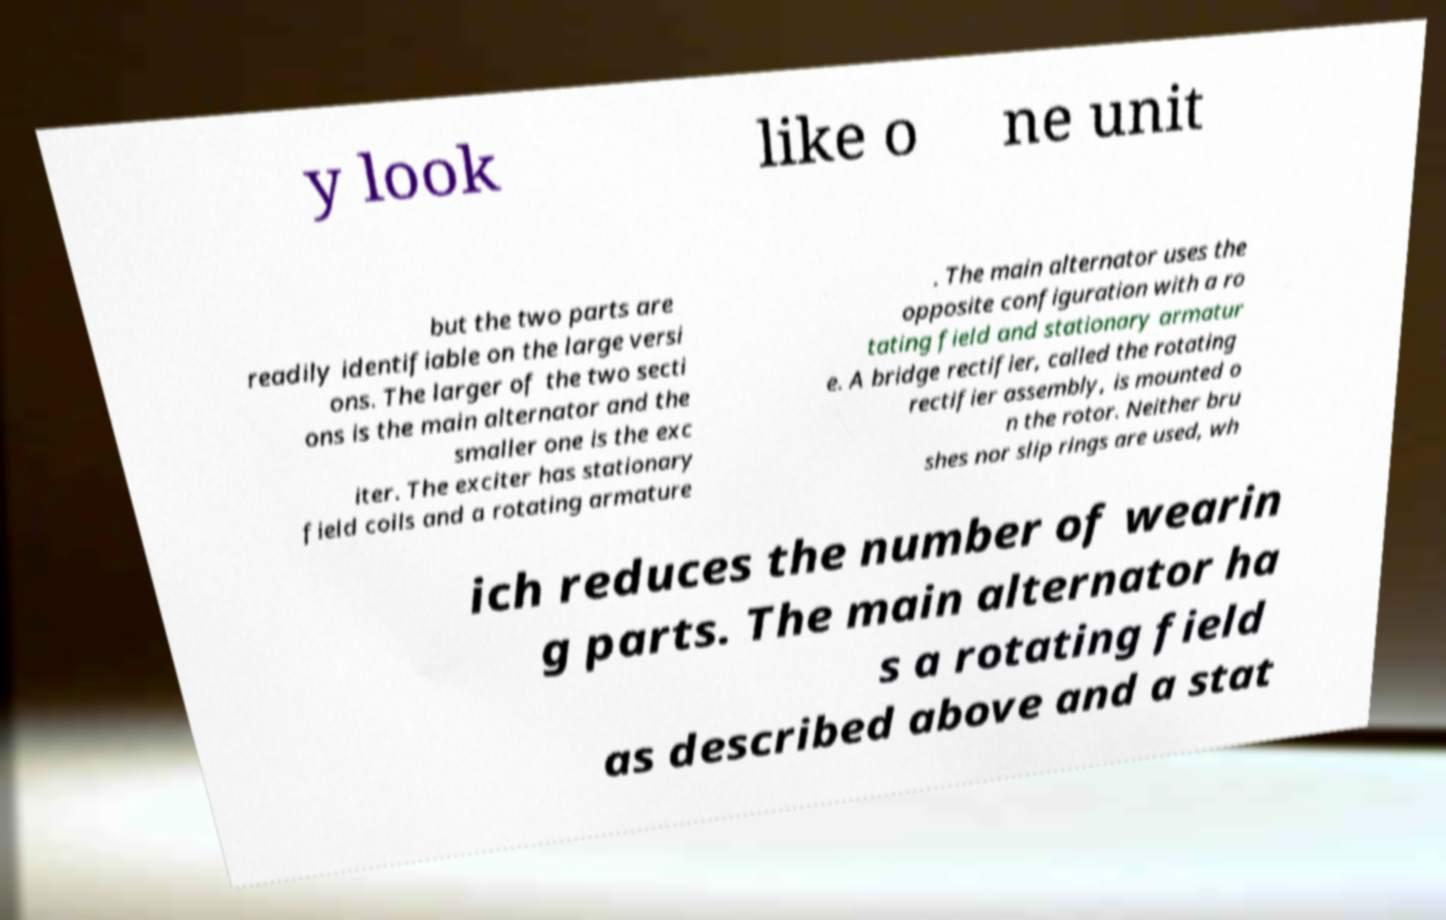Could you assist in decoding the text presented in this image and type it out clearly? y look like o ne unit but the two parts are readily identifiable on the large versi ons. The larger of the two secti ons is the main alternator and the smaller one is the exc iter. The exciter has stationary field coils and a rotating armature . The main alternator uses the opposite configuration with a ro tating field and stationary armatur e. A bridge rectifier, called the rotating rectifier assembly, is mounted o n the rotor. Neither bru shes nor slip rings are used, wh ich reduces the number of wearin g parts. The main alternator ha s a rotating field as described above and a stat 